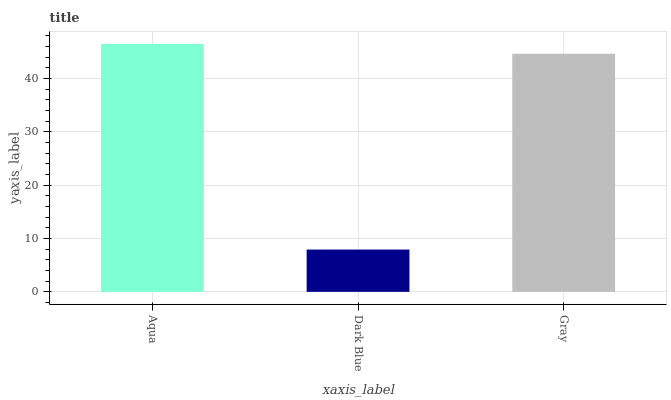Is Dark Blue the minimum?
Answer yes or no. Yes. Is Aqua the maximum?
Answer yes or no. Yes. Is Gray the minimum?
Answer yes or no. No. Is Gray the maximum?
Answer yes or no. No. Is Gray greater than Dark Blue?
Answer yes or no. Yes. Is Dark Blue less than Gray?
Answer yes or no. Yes. Is Dark Blue greater than Gray?
Answer yes or no. No. Is Gray less than Dark Blue?
Answer yes or no. No. Is Gray the high median?
Answer yes or no. Yes. Is Gray the low median?
Answer yes or no. Yes. Is Aqua the high median?
Answer yes or no. No. Is Aqua the low median?
Answer yes or no. No. 